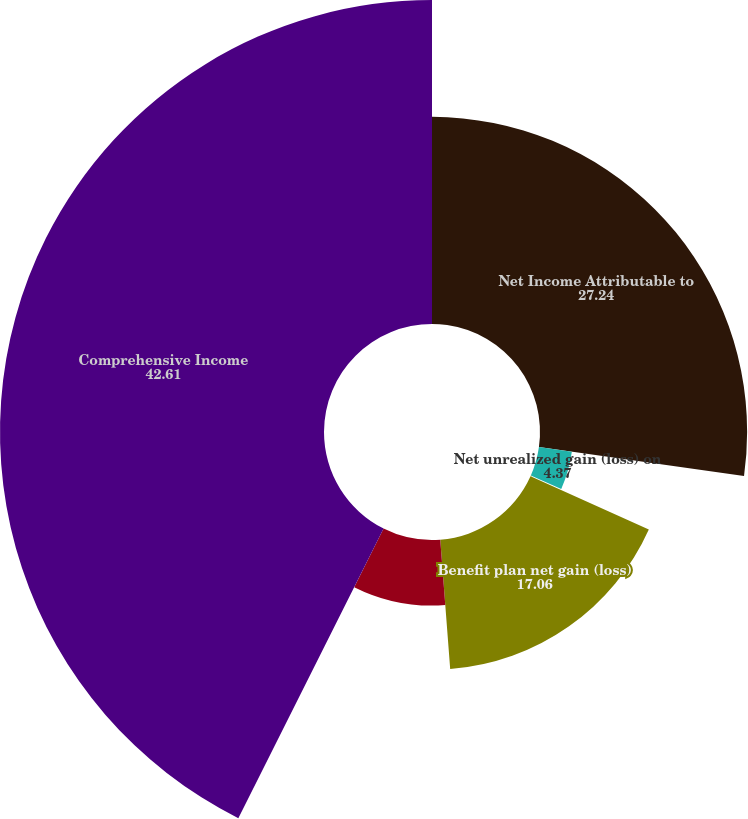<chart> <loc_0><loc_0><loc_500><loc_500><pie_chart><fcel>Net Income Attributable to<fcel>Net unrealized gain (loss) on<fcel>Net unrealized (loss) gain on<fcel>Benefit plan net gain (loss)<fcel>Cumulative translation<fcel>Comprehensive Income<nl><fcel>27.24%<fcel>4.37%<fcel>0.12%<fcel>17.06%<fcel>8.62%<fcel>42.61%<nl></chart> 